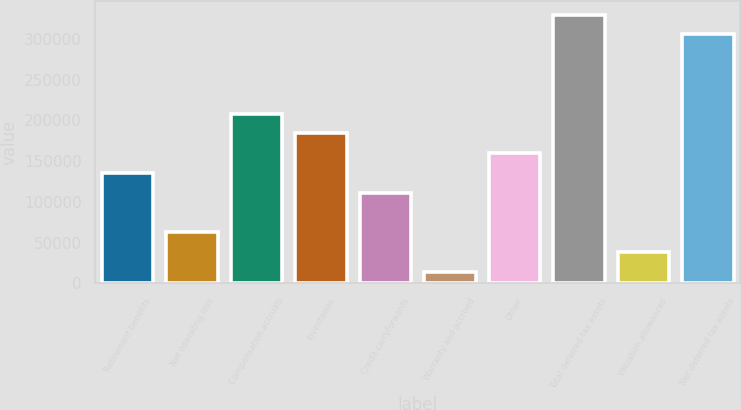Convert chart. <chart><loc_0><loc_0><loc_500><loc_500><bar_chart><fcel>Retirement benefits<fcel>Net operating loss<fcel>Compensation accruals<fcel>Inventories<fcel>Credit carryforwards<fcel>Warranty and accrued<fcel>Other<fcel>Total deferred tax assets<fcel>Valuation allowances<fcel>Net deferred tax assets<nl><fcel>135442<fcel>62524.4<fcel>208359<fcel>184053<fcel>111136<fcel>13913<fcel>159747<fcel>329887<fcel>38218.7<fcel>305581<nl></chart> 